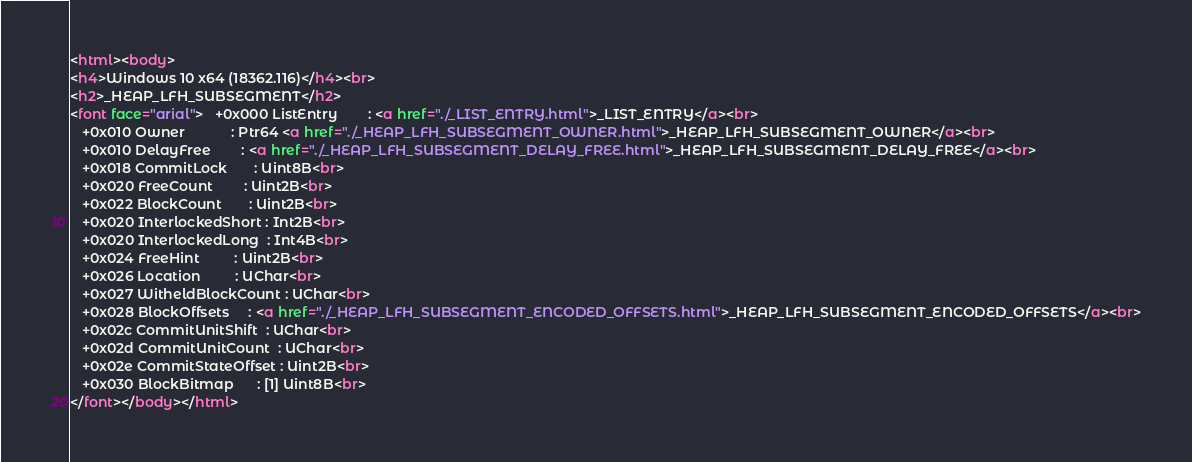Convert code to text. <code><loc_0><loc_0><loc_500><loc_500><_HTML_><html><body>
<h4>Windows 10 x64 (18362.116)</h4><br>
<h2>_HEAP_LFH_SUBSEGMENT</h2>
<font face="arial">   +0x000 ListEntry        : <a href="./_LIST_ENTRY.html">_LIST_ENTRY</a><br>
   +0x010 Owner            : Ptr64 <a href="./_HEAP_LFH_SUBSEGMENT_OWNER.html">_HEAP_LFH_SUBSEGMENT_OWNER</a><br>
   +0x010 DelayFree        : <a href="./_HEAP_LFH_SUBSEGMENT_DELAY_FREE.html">_HEAP_LFH_SUBSEGMENT_DELAY_FREE</a><br>
   +0x018 CommitLock       : Uint8B<br>
   +0x020 FreeCount        : Uint2B<br>
   +0x022 BlockCount       : Uint2B<br>
   +0x020 InterlockedShort : Int2B<br>
   +0x020 InterlockedLong  : Int4B<br>
   +0x024 FreeHint         : Uint2B<br>
   +0x026 Location         : UChar<br>
   +0x027 WitheldBlockCount : UChar<br>
   +0x028 BlockOffsets     : <a href="./_HEAP_LFH_SUBSEGMENT_ENCODED_OFFSETS.html">_HEAP_LFH_SUBSEGMENT_ENCODED_OFFSETS</a><br>
   +0x02c CommitUnitShift  : UChar<br>
   +0x02d CommitUnitCount  : UChar<br>
   +0x02e CommitStateOffset : Uint2B<br>
   +0x030 BlockBitmap      : [1] Uint8B<br>
</font></body></html></code> 